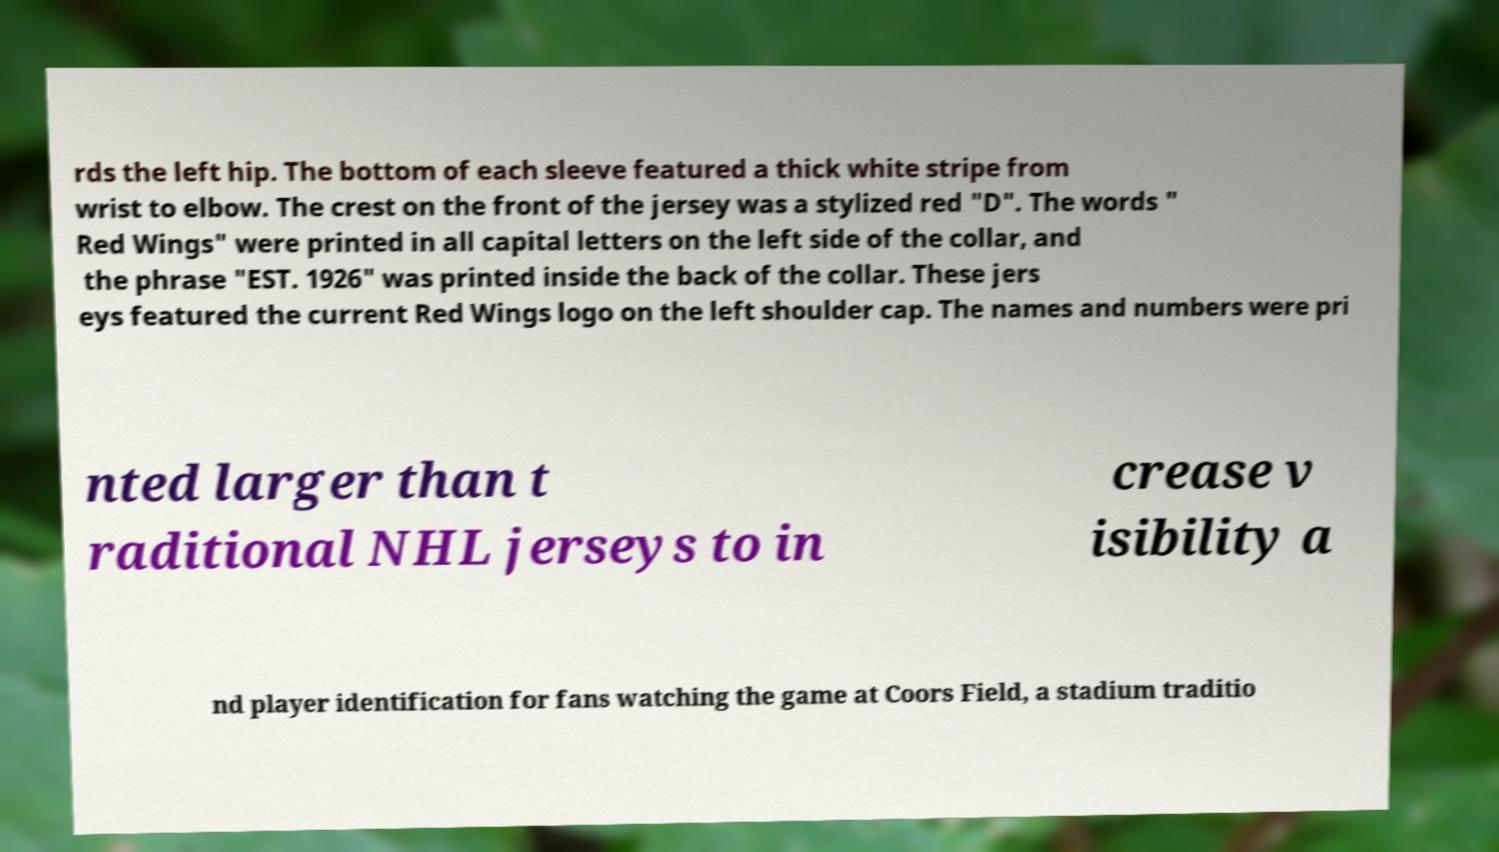Please identify and transcribe the text found in this image. rds the left hip. The bottom of each sleeve featured a thick white stripe from wrist to elbow. The crest on the front of the jersey was a stylized red "D". The words " Red Wings" were printed in all capital letters on the left side of the collar, and the phrase "EST. 1926" was printed inside the back of the collar. These jers eys featured the current Red Wings logo on the left shoulder cap. The names and numbers were pri nted larger than t raditional NHL jerseys to in crease v isibility a nd player identification for fans watching the game at Coors Field, a stadium traditio 